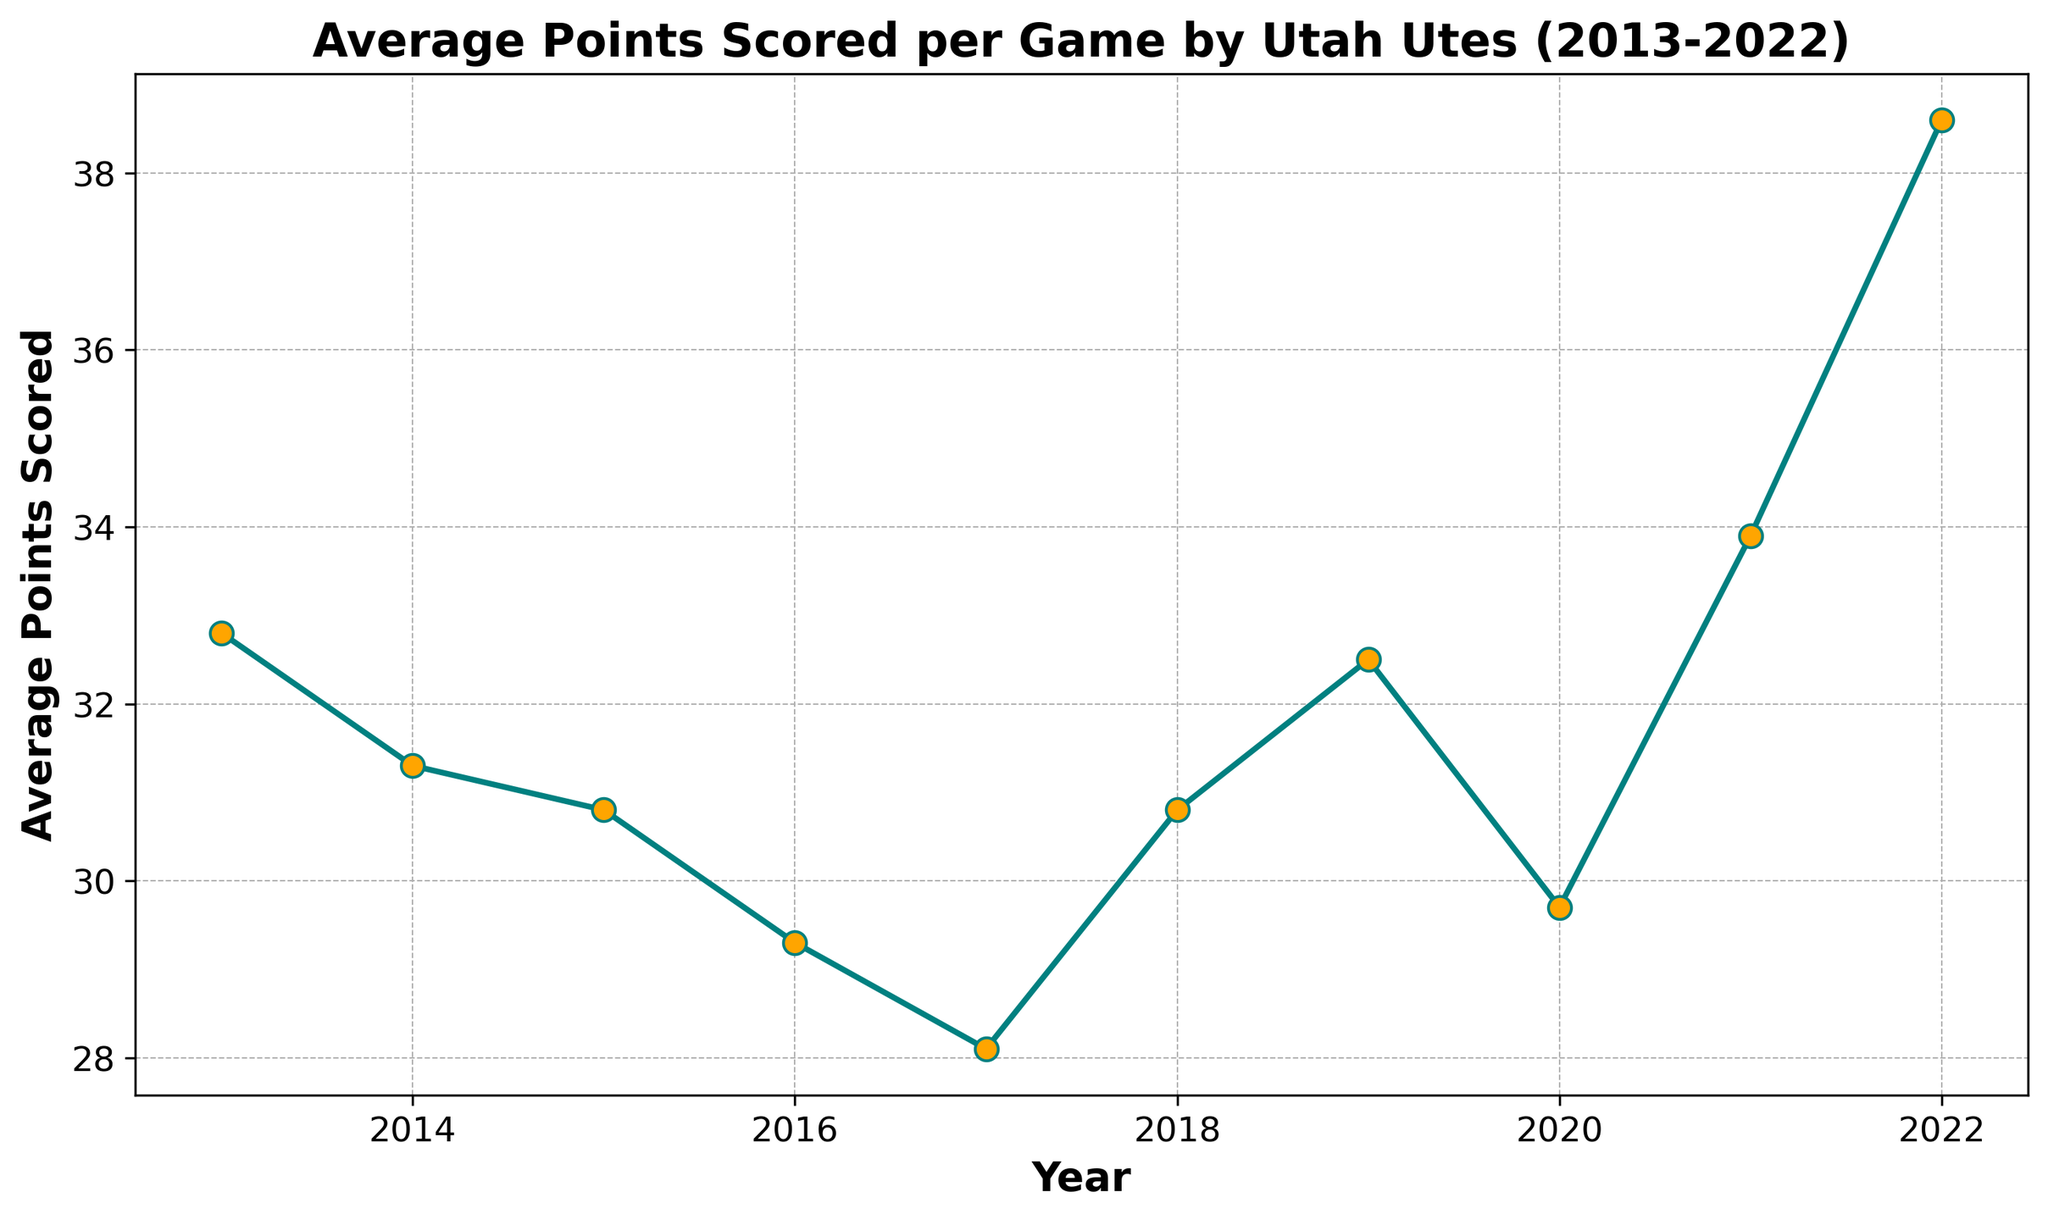What's the average of the average points scored per game from 2013 to 2018? To find the average, sum the average points from 2013 to 2018 and divide by the total years: (32.8 + 31.3 + 30.8 + 29.3 + 28.1 + 30.8) / 6 = 183.1 / 6 = 30.52
Answer: 30.52 In which year did Utah Utes score the highest average points per game? By examining the data, the highest point is at 2022 with 38.6 points.
Answer: 2022 Compare the average points scored in 2017 and 2019. Which year had a higher score and by how much? In 2017, the average points were 28.1, and in 2019 it was 32.5. The difference is 32.5 - 28.1 = 4.4 points.
Answer: 2019 by 4.4 points Looking at the trend, did the average points scored per game increase or decrease from 2013 to 2017? From 2013 (32.8) to 2017 (28.1), there is a decreasing trend in average points scored per game.
Answer: Decrease Which year shows both the lowest average points scored and what was the score? The lowest average points scored was in 2017, which was 28.1 points.
Answer: 2017 with 28.1 points By how much did the average points scored per game increase from 2020 to 2021? The average points in 2020 were 29.7, and in 2021 it was 33.9. The increase is 33.9 - 29.7 = 4.2 points.
Answer: 4.2 points Did the average points scored per game ever fall below 29 points? If yes, in which year? Yes, the average points scored fell below 29 points in 2017, where it was 28.1.
Answer: 2017 What is the difference between the highest and lowest average points scored per game over the ten years? The highest average is 38.6 (2022) and the lowest is 28.1 (2017). The difference is 38.6 - 28.1 = 10.5 points.
Answer: 10.5 points Compare the average points scored in 2015 and 2016. What is the percent change from 2015 to 2016? The average points in 2015 were 30.8, and in 2016 it was 29.3. The percent change is ((29.3 - 30.8) / 30.8) * 100 = -4.87%.
Answer: -4.87% Between 2018 and 2022, in which year did they see the largest increase in average points scored compared to its previous year? From 2018 (30.8) to 2022 (38.6), the largest increase was from 2021 (33.9) to 2022 (38.6), with an increase of 4.7 points.
Answer: 2022 